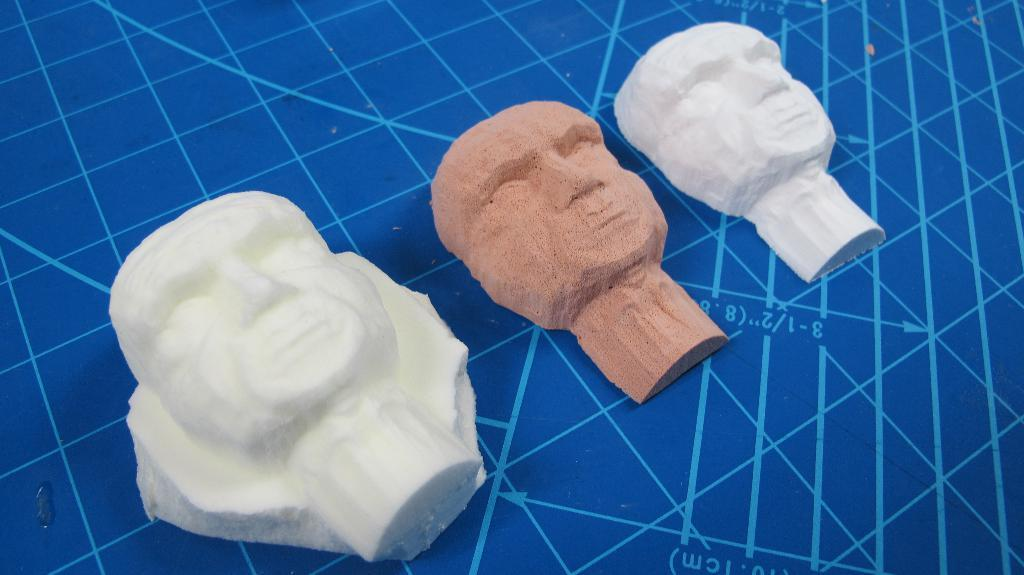What type of objects are depicted in the image? There are statues of human faces in the image. What type of spoon can be seen in the field in the image? There is no spoon or field present in the image; it only features statues of human faces. 